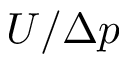<formula> <loc_0><loc_0><loc_500><loc_500>U / \Delta p</formula> 